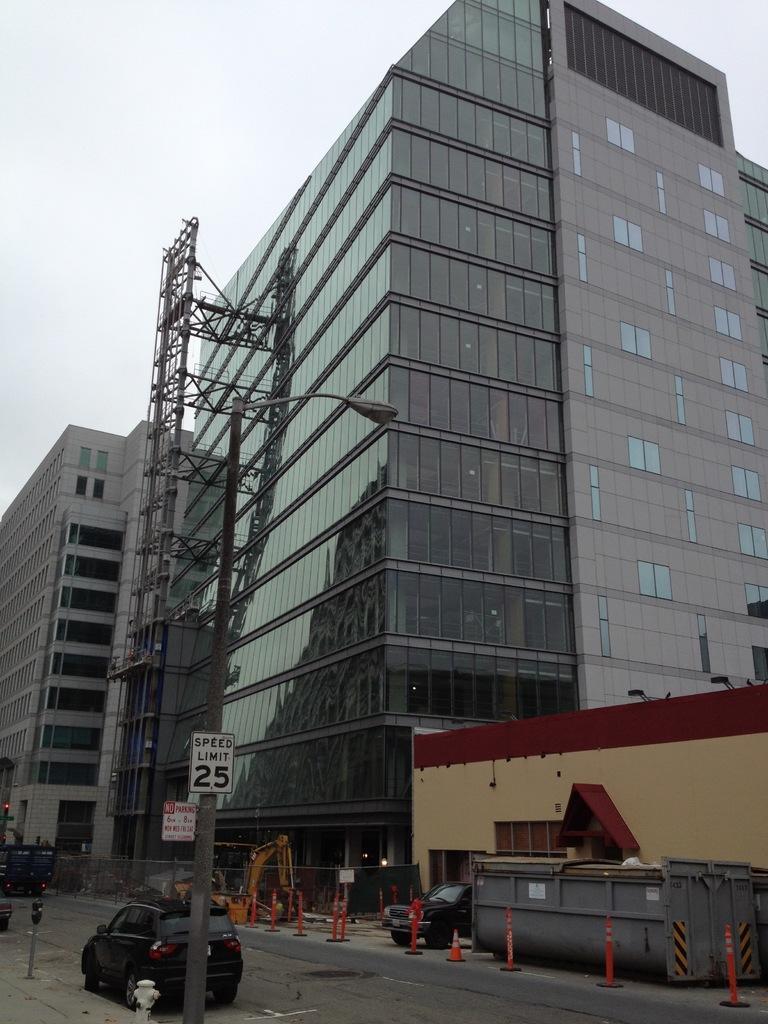Could you give a brief overview of what you see in this image? In the foreground of this image, on the road, there is a vehicle moving, a light pole and few bollards on either side to the road. In the background, there are buildings, a vehicle, crane and the sky. 